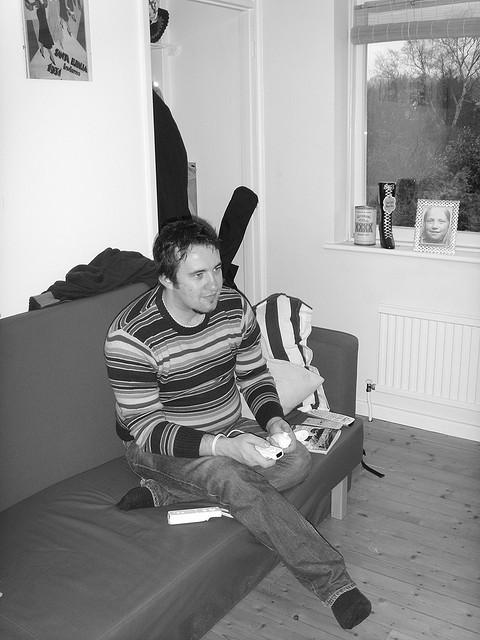What console is this person using?
Short answer required. Wii. How many people?
Give a very brief answer. 1. What is the man playing?
Keep it brief. Wii. Is the man wearing shoes?
Quick response, please. No. 